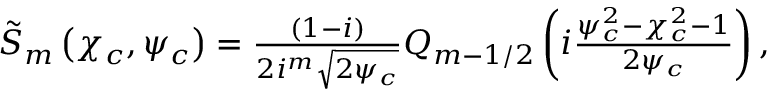<formula> <loc_0><loc_0><loc_500><loc_500>\begin{array} { r } { \tilde { S } _ { m } \left ( \chi _ { c } , \psi _ { c } \right ) = \frac { ( 1 - i ) } { 2 i ^ { m } \sqrt { 2 \psi _ { c } } } Q _ { m - 1 / 2 } \left ( i \frac { \psi _ { c } ^ { 2 } - \chi _ { c } ^ { 2 } - 1 } { 2 \psi _ { c } } \right ) , } \end{array}</formula> 